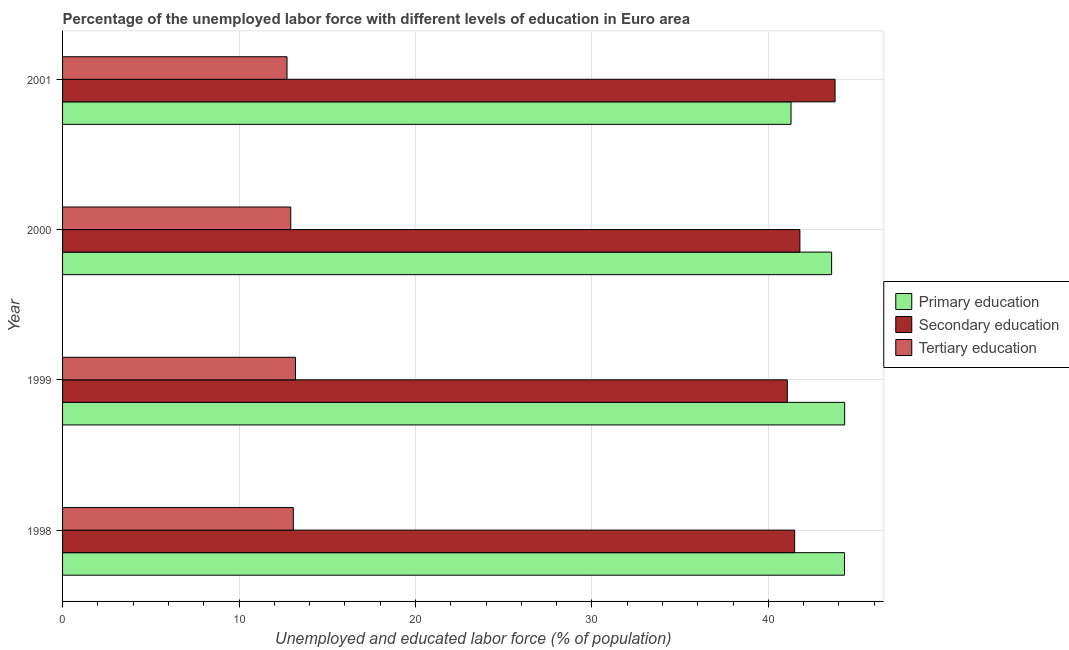How many groups of bars are there?
Make the answer very short. 4. Are the number of bars per tick equal to the number of legend labels?
Your answer should be compact. Yes. What is the label of the 4th group of bars from the top?
Your answer should be compact. 1998. What is the percentage of labor force who received primary education in 2001?
Ensure brevity in your answer.  41.29. Across all years, what is the maximum percentage of labor force who received tertiary education?
Make the answer very short. 13.2. Across all years, what is the minimum percentage of labor force who received secondary education?
Provide a short and direct response. 41.08. In which year was the percentage of labor force who received secondary education maximum?
Offer a terse response. 2001. In which year was the percentage of labor force who received tertiary education minimum?
Offer a terse response. 2001. What is the total percentage of labor force who received tertiary education in the graph?
Offer a terse response. 51.93. What is the difference between the percentage of labor force who received tertiary education in 1998 and that in 2001?
Provide a succinct answer. 0.36. What is the difference between the percentage of labor force who received tertiary education in 1999 and the percentage of labor force who received primary education in 2000?
Make the answer very short. -30.39. What is the average percentage of labor force who received tertiary education per year?
Offer a very short reply. 12.98. In the year 1998, what is the difference between the percentage of labor force who received tertiary education and percentage of labor force who received primary education?
Make the answer very short. -31.24. What is the difference between the highest and the second highest percentage of labor force who received secondary education?
Provide a succinct answer. 1.99. What is the difference between the highest and the lowest percentage of labor force who received primary education?
Offer a very short reply. 3.04. In how many years, is the percentage of labor force who received secondary education greater than the average percentage of labor force who received secondary education taken over all years?
Provide a short and direct response. 1. What does the 2nd bar from the top in 1999 represents?
Give a very brief answer. Secondary education. What does the 2nd bar from the bottom in 2001 represents?
Provide a short and direct response. Secondary education. How many years are there in the graph?
Offer a terse response. 4. Are the values on the major ticks of X-axis written in scientific E-notation?
Offer a very short reply. No. Where does the legend appear in the graph?
Offer a terse response. Center right. How are the legend labels stacked?
Your answer should be very brief. Vertical. What is the title of the graph?
Offer a terse response. Percentage of the unemployed labor force with different levels of education in Euro area. What is the label or title of the X-axis?
Provide a short and direct response. Unemployed and educated labor force (% of population). What is the label or title of the Y-axis?
Keep it short and to the point. Year. What is the Unemployed and educated labor force (% of population) in Primary education in 1998?
Make the answer very short. 44.32. What is the Unemployed and educated labor force (% of population) of Secondary education in 1998?
Provide a short and direct response. 41.49. What is the Unemployed and educated labor force (% of population) in Tertiary education in 1998?
Your answer should be compact. 13.08. What is the Unemployed and educated labor force (% of population) in Primary education in 1999?
Ensure brevity in your answer.  44.33. What is the Unemployed and educated labor force (% of population) of Secondary education in 1999?
Your answer should be very brief. 41.08. What is the Unemployed and educated labor force (% of population) of Tertiary education in 1999?
Your answer should be very brief. 13.2. What is the Unemployed and educated labor force (% of population) of Primary education in 2000?
Keep it short and to the point. 43.59. What is the Unemployed and educated labor force (% of population) in Secondary education in 2000?
Your answer should be compact. 41.79. What is the Unemployed and educated labor force (% of population) in Tertiary education in 2000?
Give a very brief answer. 12.93. What is the Unemployed and educated labor force (% of population) in Primary education in 2001?
Keep it short and to the point. 41.29. What is the Unemployed and educated labor force (% of population) of Secondary education in 2001?
Your response must be concise. 43.78. What is the Unemployed and educated labor force (% of population) of Tertiary education in 2001?
Your answer should be very brief. 12.72. Across all years, what is the maximum Unemployed and educated labor force (% of population) in Primary education?
Keep it short and to the point. 44.33. Across all years, what is the maximum Unemployed and educated labor force (% of population) in Secondary education?
Offer a very short reply. 43.78. Across all years, what is the maximum Unemployed and educated labor force (% of population) in Tertiary education?
Make the answer very short. 13.2. Across all years, what is the minimum Unemployed and educated labor force (% of population) of Primary education?
Ensure brevity in your answer.  41.29. Across all years, what is the minimum Unemployed and educated labor force (% of population) in Secondary education?
Your answer should be compact. 41.08. Across all years, what is the minimum Unemployed and educated labor force (% of population) in Tertiary education?
Your answer should be compact. 12.72. What is the total Unemployed and educated labor force (% of population) of Primary education in the graph?
Your answer should be compact. 173.52. What is the total Unemployed and educated labor force (% of population) in Secondary education in the graph?
Ensure brevity in your answer.  168.14. What is the total Unemployed and educated labor force (% of population) in Tertiary education in the graph?
Keep it short and to the point. 51.93. What is the difference between the Unemployed and educated labor force (% of population) in Primary education in 1998 and that in 1999?
Provide a short and direct response. -0.01. What is the difference between the Unemployed and educated labor force (% of population) of Secondary education in 1998 and that in 1999?
Offer a terse response. 0.42. What is the difference between the Unemployed and educated labor force (% of population) of Tertiary education in 1998 and that in 1999?
Ensure brevity in your answer.  -0.12. What is the difference between the Unemployed and educated labor force (% of population) of Primary education in 1998 and that in 2000?
Your response must be concise. 0.73. What is the difference between the Unemployed and educated labor force (% of population) of Secondary education in 1998 and that in 2000?
Your answer should be compact. -0.3. What is the difference between the Unemployed and educated labor force (% of population) in Tertiary education in 1998 and that in 2000?
Your answer should be compact. 0.14. What is the difference between the Unemployed and educated labor force (% of population) of Primary education in 1998 and that in 2001?
Keep it short and to the point. 3.03. What is the difference between the Unemployed and educated labor force (% of population) in Secondary education in 1998 and that in 2001?
Give a very brief answer. -2.29. What is the difference between the Unemployed and educated labor force (% of population) in Tertiary education in 1998 and that in 2001?
Provide a short and direct response. 0.36. What is the difference between the Unemployed and educated labor force (% of population) in Primary education in 1999 and that in 2000?
Ensure brevity in your answer.  0.74. What is the difference between the Unemployed and educated labor force (% of population) in Secondary education in 1999 and that in 2000?
Make the answer very short. -0.71. What is the difference between the Unemployed and educated labor force (% of population) of Tertiary education in 1999 and that in 2000?
Your answer should be compact. 0.27. What is the difference between the Unemployed and educated labor force (% of population) of Primary education in 1999 and that in 2001?
Your answer should be very brief. 3.04. What is the difference between the Unemployed and educated labor force (% of population) of Secondary education in 1999 and that in 2001?
Provide a succinct answer. -2.71. What is the difference between the Unemployed and educated labor force (% of population) of Tertiary education in 1999 and that in 2001?
Your answer should be compact. 0.48. What is the difference between the Unemployed and educated labor force (% of population) in Primary education in 2000 and that in 2001?
Make the answer very short. 2.3. What is the difference between the Unemployed and educated labor force (% of population) in Secondary education in 2000 and that in 2001?
Keep it short and to the point. -1.99. What is the difference between the Unemployed and educated labor force (% of population) of Tertiary education in 2000 and that in 2001?
Your answer should be compact. 0.21. What is the difference between the Unemployed and educated labor force (% of population) of Primary education in 1998 and the Unemployed and educated labor force (% of population) of Secondary education in 1999?
Your response must be concise. 3.24. What is the difference between the Unemployed and educated labor force (% of population) in Primary education in 1998 and the Unemployed and educated labor force (% of population) in Tertiary education in 1999?
Offer a terse response. 31.12. What is the difference between the Unemployed and educated labor force (% of population) in Secondary education in 1998 and the Unemployed and educated labor force (% of population) in Tertiary education in 1999?
Give a very brief answer. 28.29. What is the difference between the Unemployed and educated labor force (% of population) in Primary education in 1998 and the Unemployed and educated labor force (% of population) in Secondary education in 2000?
Your response must be concise. 2.53. What is the difference between the Unemployed and educated labor force (% of population) of Primary education in 1998 and the Unemployed and educated labor force (% of population) of Tertiary education in 2000?
Offer a very short reply. 31.38. What is the difference between the Unemployed and educated labor force (% of population) in Secondary education in 1998 and the Unemployed and educated labor force (% of population) in Tertiary education in 2000?
Give a very brief answer. 28.56. What is the difference between the Unemployed and educated labor force (% of population) of Primary education in 1998 and the Unemployed and educated labor force (% of population) of Secondary education in 2001?
Keep it short and to the point. 0.53. What is the difference between the Unemployed and educated labor force (% of population) of Primary education in 1998 and the Unemployed and educated labor force (% of population) of Tertiary education in 2001?
Your response must be concise. 31.6. What is the difference between the Unemployed and educated labor force (% of population) of Secondary education in 1998 and the Unemployed and educated labor force (% of population) of Tertiary education in 2001?
Provide a short and direct response. 28.77. What is the difference between the Unemployed and educated labor force (% of population) in Primary education in 1999 and the Unemployed and educated labor force (% of population) in Secondary education in 2000?
Keep it short and to the point. 2.54. What is the difference between the Unemployed and educated labor force (% of population) of Primary education in 1999 and the Unemployed and educated labor force (% of population) of Tertiary education in 2000?
Make the answer very short. 31.39. What is the difference between the Unemployed and educated labor force (% of population) of Secondary education in 1999 and the Unemployed and educated labor force (% of population) of Tertiary education in 2000?
Offer a very short reply. 28.14. What is the difference between the Unemployed and educated labor force (% of population) in Primary education in 1999 and the Unemployed and educated labor force (% of population) in Secondary education in 2001?
Offer a terse response. 0.54. What is the difference between the Unemployed and educated labor force (% of population) of Primary education in 1999 and the Unemployed and educated labor force (% of population) of Tertiary education in 2001?
Give a very brief answer. 31.6. What is the difference between the Unemployed and educated labor force (% of population) of Secondary education in 1999 and the Unemployed and educated labor force (% of population) of Tertiary education in 2001?
Keep it short and to the point. 28.36. What is the difference between the Unemployed and educated labor force (% of population) in Primary education in 2000 and the Unemployed and educated labor force (% of population) in Secondary education in 2001?
Provide a short and direct response. -0.2. What is the difference between the Unemployed and educated labor force (% of population) of Primary education in 2000 and the Unemployed and educated labor force (% of population) of Tertiary education in 2001?
Keep it short and to the point. 30.87. What is the difference between the Unemployed and educated labor force (% of population) in Secondary education in 2000 and the Unemployed and educated labor force (% of population) in Tertiary education in 2001?
Provide a short and direct response. 29.07. What is the average Unemployed and educated labor force (% of population) in Primary education per year?
Offer a very short reply. 43.38. What is the average Unemployed and educated labor force (% of population) in Secondary education per year?
Provide a succinct answer. 42.03. What is the average Unemployed and educated labor force (% of population) in Tertiary education per year?
Your response must be concise. 12.98. In the year 1998, what is the difference between the Unemployed and educated labor force (% of population) in Primary education and Unemployed and educated labor force (% of population) in Secondary education?
Offer a terse response. 2.82. In the year 1998, what is the difference between the Unemployed and educated labor force (% of population) of Primary education and Unemployed and educated labor force (% of population) of Tertiary education?
Provide a succinct answer. 31.24. In the year 1998, what is the difference between the Unemployed and educated labor force (% of population) in Secondary education and Unemployed and educated labor force (% of population) in Tertiary education?
Give a very brief answer. 28.42. In the year 1999, what is the difference between the Unemployed and educated labor force (% of population) of Primary education and Unemployed and educated labor force (% of population) of Secondary education?
Keep it short and to the point. 3.25. In the year 1999, what is the difference between the Unemployed and educated labor force (% of population) of Primary education and Unemployed and educated labor force (% of population) of Tertiary education?
Ensure brevity in your answer.  31.13. In the year 1999, what is the difference between the Unemployed and educated labor force (% of population) of Secondary education and Unemployed and educated labor force (% of population) of Tertiary education?
Provide a short and direct response. 27.88. In the year 2000, what is the difference between the Unemployed and educated labor force (% of population) of Primary education and Unemployed and educated labor force (% of population) of Secondary education?
Offer a very short reply. 1.8. In the year 2000, what is the difference between the Unemployed and educated labor force (% of population) in Primary education and Unemployed and educated labor force (% of population) in Tertiary education?
Make the answer very short. 30.66. In the year 2000, what is the difference between the Unemployed and educated labor force (% of population) of Secondary education and Unemployed and educated labor force (% of population) of Tertiary education?
Ensure brevity in your answer.  28.86. In the year 2001, what is the difference between the Unemployed and educated labor force (% of population) of Primary education and Unemployed and educated labor force (% of population) of Secondary education?
Ensure brevity in your answer.  -2.5. In the year 2001, what is the difference between the Unemployed and educated labor force (% of population) of Primary education and Unemployed and educated labor force (% of population) of Tertiary education?
Offer a very short reply. 28.57. In the year 2001, what is the difference between the Unemployed and educated labor force (% of population) of Secondary education and Unemployed and educated labor force (% of population) of Tertiary education?
Make the answer very short. 31.06. What is the ratio of the Unemployed and educated labor force (% of population) in Secondary education in 1998 to that in 1999?
Your response must be concise. 1.01. What is the ratio of the Unemployed and educated labor force (% of population) in Tertiary education in 1998 to that in 1999?
Offer a terse response. 0.99. What is the ratio of the Unemployed and educated labor force (% of population) in Primary education in 1998 to that in 2000?
Provide a succinct answer. 1.02. What is the ratio of the Unemployed and educated labor force (% of population) in Secondary education in 1998 to that in 2000?
Provide a succinct answer. 0.99. What is the ratio of the Unemployed and educated labor force (% of population) in Tertiary education in 1998 to that in 2000?
Offer a very short reply. 1.01. What is the ratio of the Unemployed and educated labor force (% of population) in Primary education in 1998 to that in 2001?
Your answer should be compact. 1.07. What is the ratio of the Unemployed and educated labor force (% of population) of Secondary education in 1998 to that in 2001?
Your response must be concise. 0.95. What is the ratio of the Unemployed and educated labor force (% of population) in Tertiary education in 1998 to that in 2001?
Provide a short and direct response. 1.03. What is the ratio of the Unemployed and educated labor force (% of population) in Primary education in 1999 to that in 2000?
Your response must be concise. 1.02. What is the ratio of the Unemployed and educated labor force (% of population) in Secondary education in 1999 to that in 2000?
Offer a very short reply. 0.98. What is the ratio of the Unemployed and educated labor force (% of population) of Tertiary education in 1999 to that in 2000?
Provide a succinct answer. 1.02. What is the ratio of the Unemployed and educated labor force (% of population) in Primary education in 1999 to that in 2001?
Offer a terse response. 1.07. What is the ratio of the Unemployed and educated labor force (% of population) in Secondary education in 1999 to that in 2001?
Ensure brevity in your answer.  0.94. What is the ratio of the Unemployed and educated labor force (% of population) in Tertiary education in 1999 to that in 2001?
Give a very brief answer. 1.04. What is the ratio of the Unemployed and educated labor force (% of population) in Primary education in 2000 to that in 2001?
Your answer should be compact. 1.06. What is the ratio of the Unemployed and educated labor force (% of population) in Secondary education in 2000 to that in 2001?
Keep it short and to the point. 0.95. What is the ratio of the Unemployed and educated labor force (% of population) in Tertiary education in 2000 to that in 2001?
Provide a short and direct response. 1.02. What is the difference between the highest and the second highest Unemployed and educated labor force (% of population) of Primary education?
Your answer should be compact. 0.01. What is the difference between the highest and the second highest Unemployed and educated labor force (% of population) of Secondary education?
Keep it short and to the point. 1.99. What is the difference between the highest and the second highest Unemployed and educated labor force (% of population) of Tertiary education?
Your response must be concise. 0.12. What is the difference between the highest and the lowest Unemployed and educated labor force (% of population) in Primary education?
Keep it short and to the point. 3.04. What is the difference between the highest and the lowest Unemployed and educated labor force (% of population) in Secondary education?
Give a very brief answer. 2.71. What is the difference between the highest and the lowest Unemployed and educated labor force (% of population) of Tertiary education?
Your answer should be compact. 0.48. 